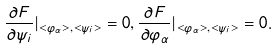Convert formula to latex. <formula><loc_0><loc_0><loc_500><loc_500>\frac { \partial F } { \partial \psi _ { i } } | _ { < \varphi _ { \alpha } > , < \psi _ { i } > } = 0 , \frac { \partial F } { \partial \varphi _ { \alpha } } | _ { < \varphi _ { \alpha } > , < \psi _ { i } > } = 0 .</formula> 